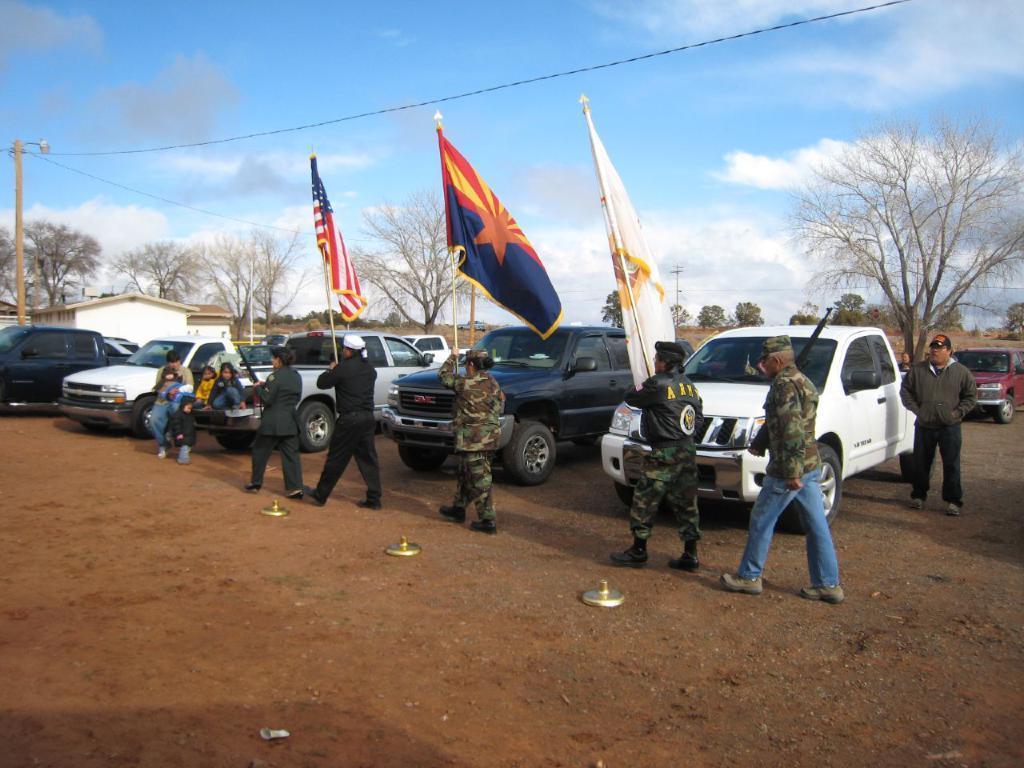How would you summarize this image in a sentence or two? This picture shows few Mini trucks parked and we see people walking and they are holding flag poles in their hands and we see a man standing on the side and he wore a cap on his head and we see few kids and a man seated and we see trees and a electrical pole and a blue cloudy sky. 